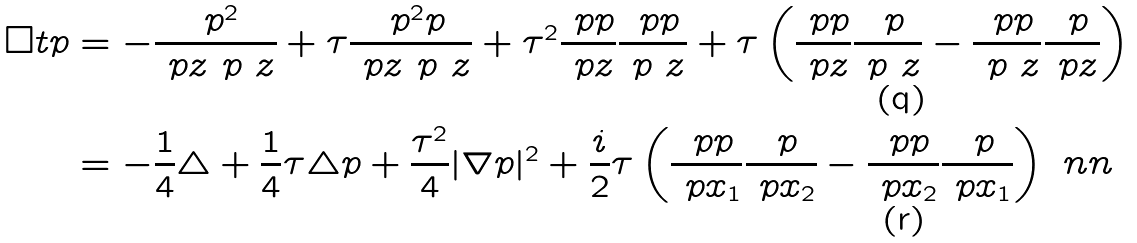<formula> <loc_0><loc_0><loc_500><loc_500>\Box t p & = - \frac { \ p ^ { 2 } } { \ p z \ p \ z } + \tau \frac { \ p ^ { 2 } p } { \ p z \ p \ z } + \tau ^ { 2 } \frac { \ p p } { \ p z } \frac { \ p p } { \ p \ z } + \tau \left ( \frac { \ p p } { \ p z } \frac { \ p } { \ p \ z } - \frac { \ p p } { \ p \ z } \frac { \ p } { \ p z } \right ) \\ & = - \frac { 1 } { 4 } \triangle + \frac { 1 } { 4 } \tau \triangle p + \frac { \tau ^ { 2 } } 4 | \nabla p | ^ { 2 } + \frac { i } { 2 } \tau \left ( \frac { \ p p } { \ p x _ { 1 } } \frac { \ p } { \ p x _ { 2 } } - \frac { \ p p } { \ p x _ { 2 } } \frac { \ p } { \ p x _ { 1 } } \right ) \ n n</formula> 